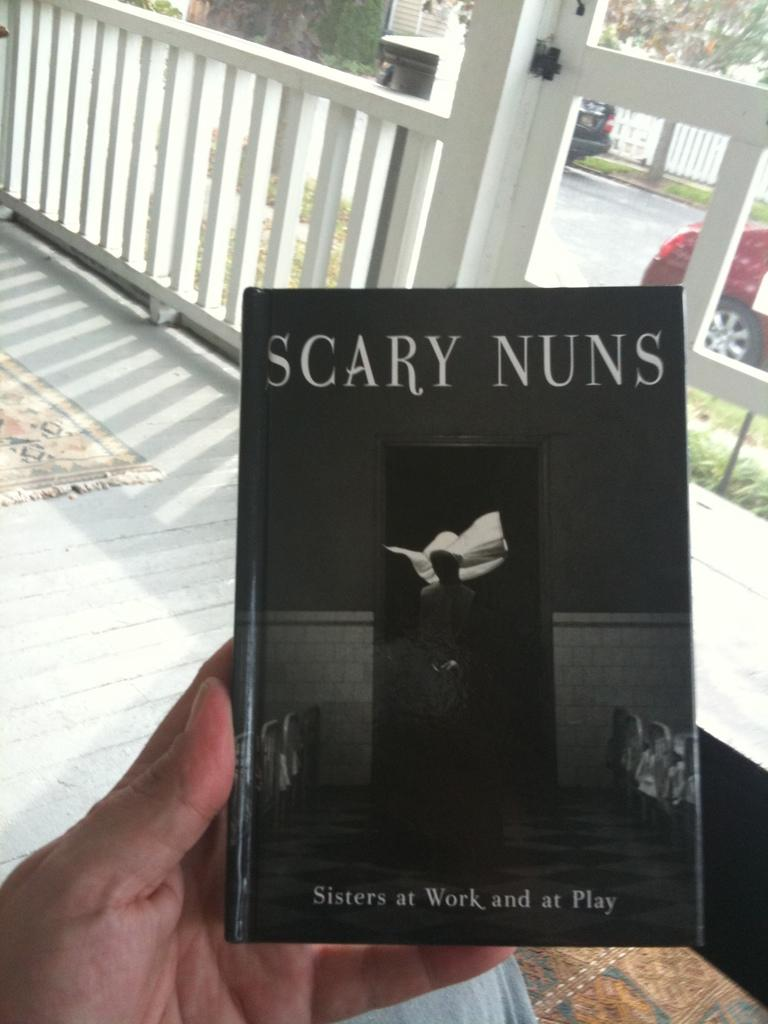<image>
Describe the image concisely. A person is holding a book called "Scary Nuns" while sitting on a porch. 